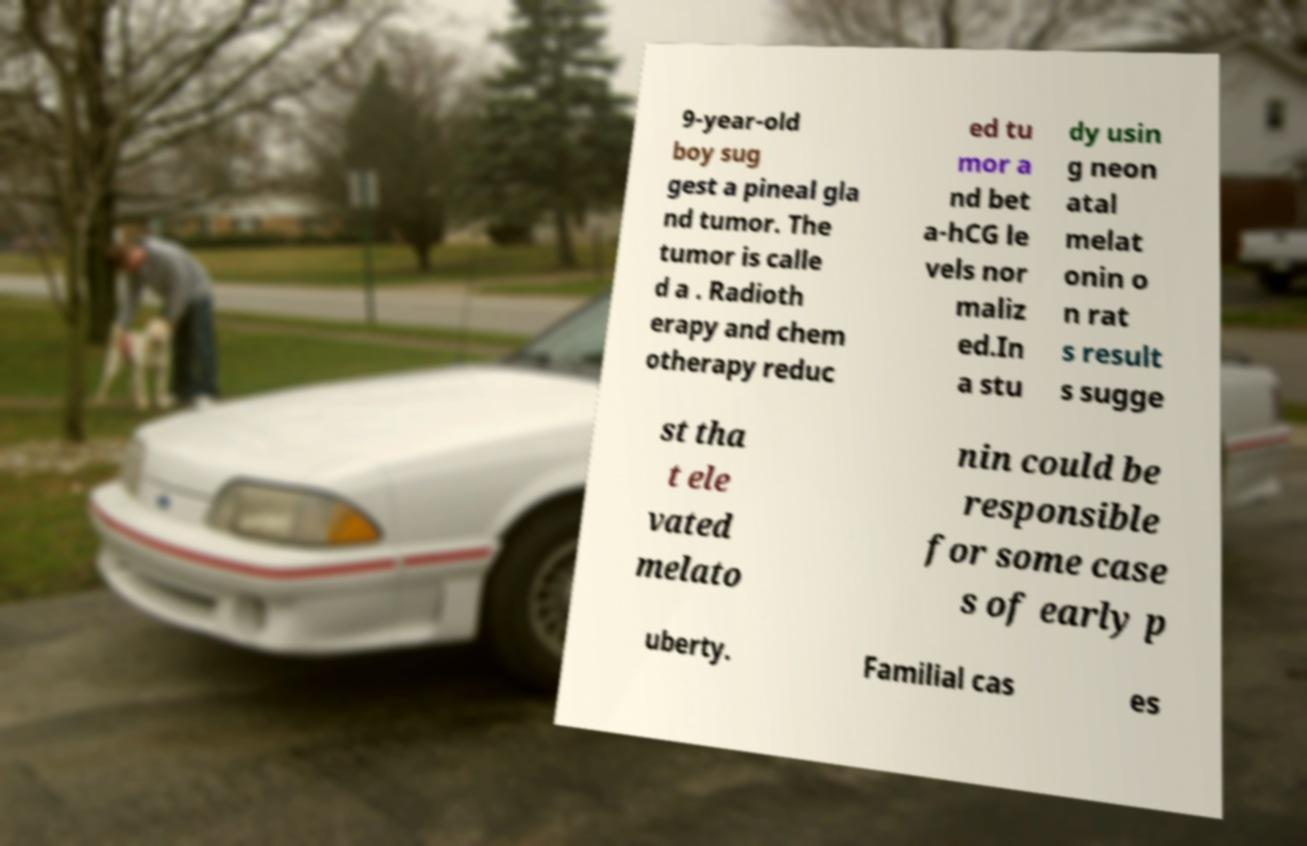Can you accurately transcribe the text from the provided image for me? 9-year-old boy sug gest a pineal gla nd tumor. The tumor is calle d a . Radioth erapy and chem otherapy reduc ed tu mor a nd bet a-hCG le vels nor maliz ed.In a stu dy usin g neon atal melat onin o n rat s result s sugge st tha t ele vated melato nin could be responsible for some case s of early p uberty. Familial cas es 